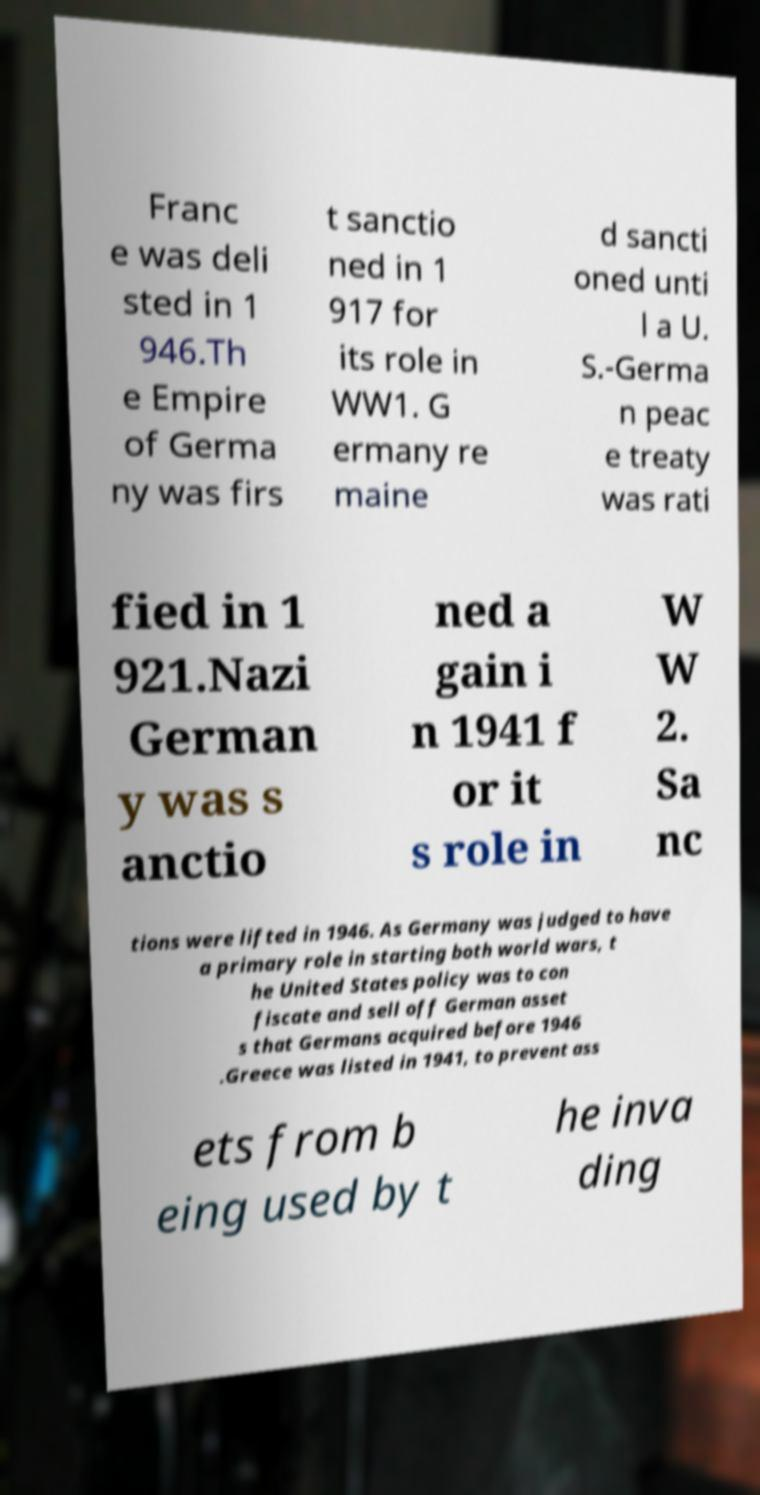What messages or text are displayed in this image? I need them in a readable, typed format. Franc e was deli sted in 1 946.Th e Empire of Germa ny was firs t sanctio ned in 1 917 for its role in WW1. G ermany re maine d sancti oned unti l a U. S.-Germa n peac e treaty was rati fied in 1 921.Nazi German y was s anctio ned a gain i n 1941 f or it s role in W W 2. Sa nc tions were lifted in 1946. As Germany was judged to have a primary role in starting both world wars, t he United States policy was to con fiscate and sell off German asset s that Germans acquired before 1946 .Greece was listed in 1941, to prevent ass ets from b eing used by t he inva ding 